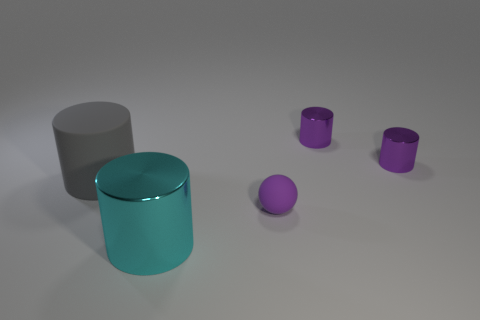What is the color of the thing that is both left of the tiny purple ball and behind the purple matte sphere?
Ensure brevity in your answer.  Gray. Is the number of things that are on the left side of the tiny purple ball greater than the number of small metal cylinders that are to the left of the gray object?
Offer a terse response. Yes. What size is the gray cylinder that is the same material as the small ball?
Your response must be concise. Large. There is a small purple thing that is in front of the big gray matte object; what number of cyan shiny cylinders are on the right side of it?
Give a very brief answer. 0. Is there a purple shiny thing of the same shape as the gray matte object?
Your response must be concise. Yes. There is a shiny cylinder to the left of the matte thing that is on the right side of the big rubber object; what color is it?
Your answer should be very brief. Cyan. Are there more big gray rubber objects than tiny purple things?
Make the answer very short. No. What number of purple metallic cylinders are the same size as the matte sphere?
Your answer should be compact. 2. Is the cyan thing made of the same material as the tiny purple thing that is in front of the gray matte cylinder?
Offer a very short reply. No. Is the number of cyan cylinders less than the number of small objects?
Provide a short and direct response. Yes. 